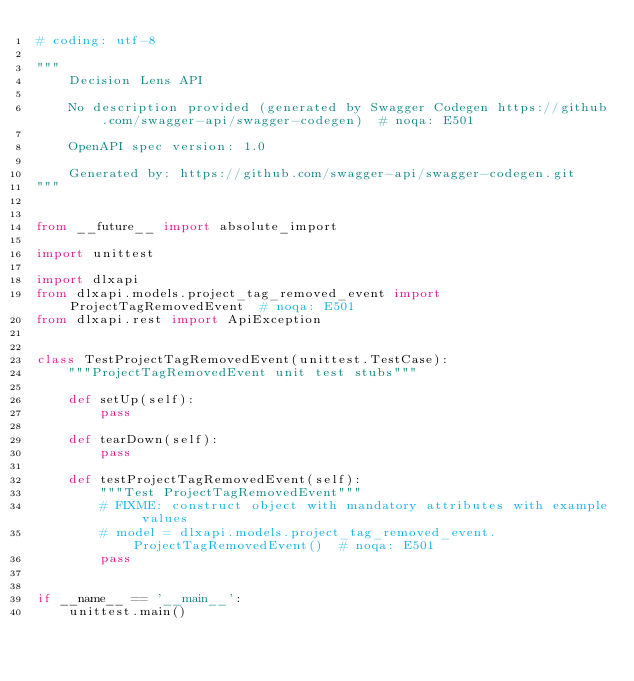<code> <loc_0><loc_0><loc_500><loc_500><_Python_># coding: utf-8

"""
    Decision Lens API

    No description provided (generated by Swagger Codegen https://github.com/swagger-api/swagger-codegen)  # noqa: E501

    OpenAPI spec version: 1.0
    
    Generated by: https://github.com/swagger-api/swagger-codegen.git
"""


from __future__ import absolute_import

import unittest

import dlxapi
from dlxapi.models.project_tag_removed_event import ProjectTagRemovedEvent  # noqa: E501
from dlxapi.rest import ApiException


class TestProjectTagRemovedEvent(unittest.TestCase):
    """ProjectTagRemovedEvent unit test stubs"""

    def setUp(self):
        pass

    def tearDown(self):
        pass

    def testProjectTagRemovedEvent(self):
        """Test ProjectTagRemovedEvent"""
        # FIXME: construct object with mandatory attributes with example values
        # model = dlxapi.models.project_tag_removed_event.ProjectTagRemovedEvent()  # noqa: E501
        pass


if __name__ == '__main__':
    unittest.main()
</code> 